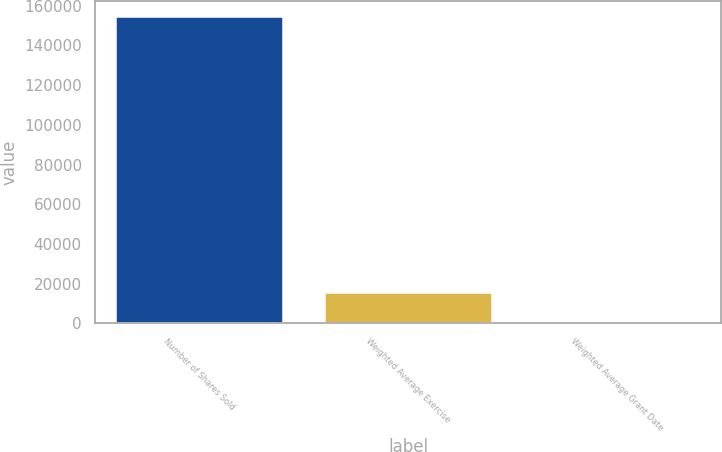<chart> <loc_0><loc_0><loc_500><loc_500><bar_chart><fcel>Number of Shares Sold<fcel>Weighted Average Exercise<fcel>Weighted Average Grant Date<nl><fcel>154395<fcel>15442.5<fcel>3.29<nl></chart> 